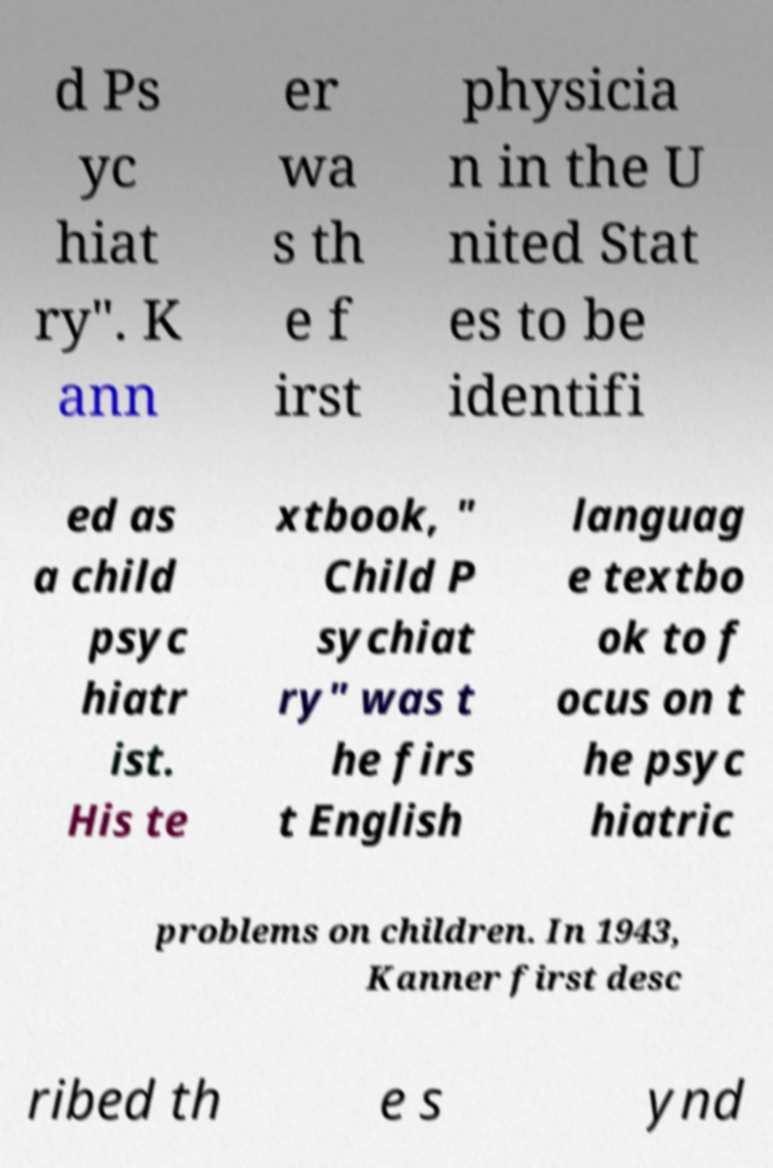I need the written content from this picture converted into text. Can you do that? d Ps yc hiat ry". K ann er wa s th e f irst physicia n in the U nited Stat es to be identifi ed as a child psyc hiatr ist. His te xtbook, " Child P sychiat ry" was t he firs t English languag e textbo ok to f ocus on t he psyc hiatric problems on children. In 1943, Kanner first desc ribed th e s ynd 